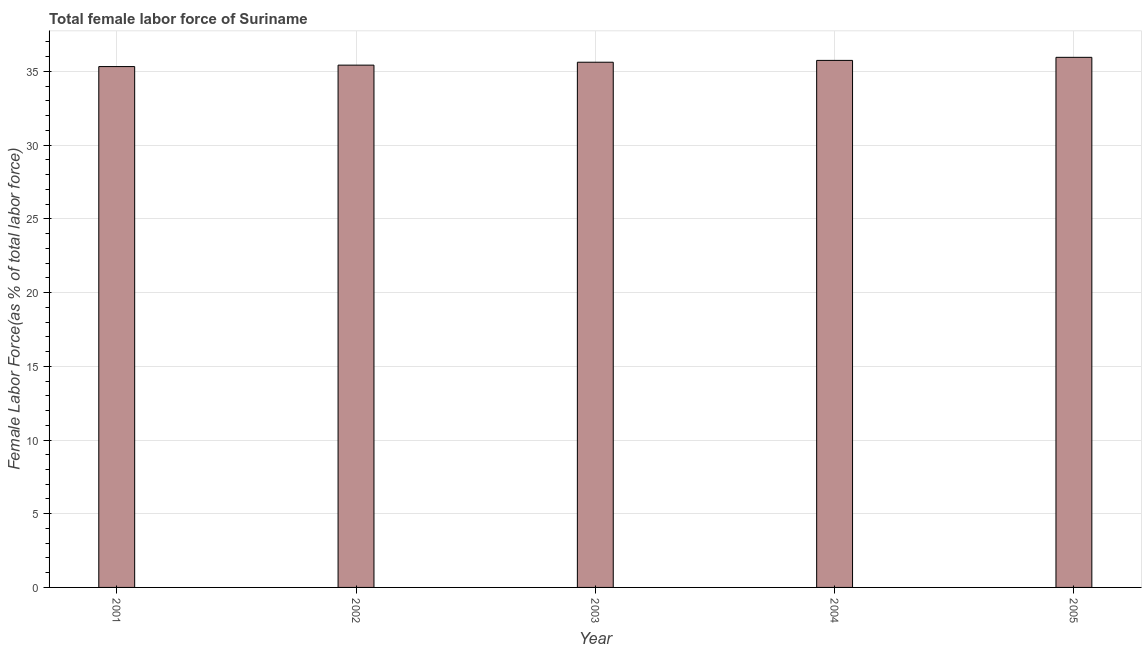Does the graph contain any zero values?
Offer a terse response. No. What is the title of the graph?
Offer a very short reply. Total female labor force of Suriname. What is the label or title of the X-axis?
Make the answer very short. Year. What is the label or title of the Y-axis?
Make the answer very short. Female Labor Force(as % of total labor force). What is the total female labor force in 2002?
Offer a terse response. 35.43. Across all years, what is the maximum total female labor force?
Give a very brief answer. 35.96. Across all years, what is the minimum total female labor force?
Ensure brevity in your answer.  35.33. In which year was the total female labor force maximum?
Your response must be concise. 2005. In which year was the total female labor force minimum?
Provide a short and direct response. 2001. What is the sum of the total female labor force?
Ensure brevity in your answer.  178.1. What is the difference between the total female labor force in 2001 and 2004?
Offer a terse response. -0.42. What is the average total female labor force per year?
Offer a terse response. 35.62. What is the median total female labor force?
Give a very brief answer. 35.63. Do a majority of the years between 2003 and 2004 (inclusive) have total female labor force greater than 26 %?
Keep it short and to the point. Yes. What is the ratio of the total female labor force in 2001 to that in 2002?
Offer a very short reply. 1. What is the difference between the highest and the second highest total female labor force?
Your response must be concise. 0.21. Is the sum of the total female labor force in 2001 and 2005 greater than the maximum total female labor force across all years?
Provide a succinct answer. Yes. What is the difference between the highest and the lowest total female labor force?
Ensure brevity in your answer.  0.63. Are all the bars in the graph horizontal?
Your answer should be very brief. No. What is the difference between two consecutive major ticks on the Y-axis?
Make the answer very short. 5. What is the Female Labor Force(as % of total labor force) of 2001?
Offer a very short reply. 35.33. What is the Female Labor Force(as % of total labor force) of 2002?
Make the answer very short. 35.43. What is the Female Labor Force(as % of total labor force) of 2003?
Give a very brief answer. 35.63. What is the Female Labor Force(as % of total labor force) of 2004?
Keep it short and to the point. 35.75. What is the Female Labor Force(as % of total labor force) of 2005?
Provide a short and direct response. 35.96. What is the difference between the Female Labor Force(as % of total labor force) in 2001 and 2002?
Offer a very short reply. -0.1. What is the difference between the Female Labor Force(as % of total labor force) in 2001 and 2003?
Provide a short and direct response. -0.29. What is the difference between the Female Labor Force(as % of total labor force) in 2001 and 2004?
Offer a very short reply. -0.42. What is the difference between the Female Labor Force(as % of total labor force) in 2001 and 2005?
Ensure brevity in your answer.  -0.63. What is the difference between the Female Labor Force(as % of total labor force) in 2002 and 2003?
Your response must be concise. -0.2. What is the difference between the Female Labor Force(as % of total labor force) in 2002 and 2004?
Provide a succinct answer. -0.32. What is the difference between the Female Labor Force(as % of total labor force) in 2002 and 2005?
Give a very brief answer. -0.53. What is the difference between the Female Labor Force(as % of total labor force) in 2003 and 2004?
Provide a succinct answer. -0.12. What is the difference between the Female Labor Force(as % of total labor force) in 2003 and 2005?
Make the answer very short. -0.33. What is the difference between the Female Labor Force(as % of total labor force) in 2004 and 2005?
Provide a short and direct response. -0.21. What is the ratio of the Female Labor Force(as % of total labor force) in 2001 to that in 2003?
Keep it short and to the point. 0.99. What is the ratio of the Female Labor Force(as % of total labor force) in 2001 to that in 2004?
Your answer should be very brief. 0.99. What is the ratio of the Female Labor Force(as % of total labor force) in 2002 to that in 2004?
Your response must be concise. 0.99. 